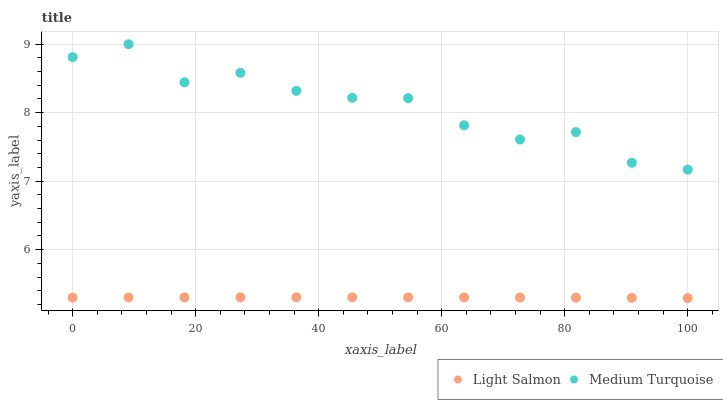Does Light Salmon have the minimum area under the curve?
Answer yes or no. Yes. Does Medium Turquoise have the maximum area under the curve?
Answer yes or no. Yes. Does Medium Turquoise have the minimum area under the curve?
Answer yes or no. No. Is Light Salmon the smoothest?
Answer yes or no. Yes. Is Medium Turquoise the roughest?
Answer yes or no. Yes. Is Medium Turquoise the smoothest?
Answer yes or no. No. Does Light Salmon have the lowest value?
Answer yes or no. Yes. Does Medium Turquoise have the lowest value?
Answer yes or no. No. Does Medium Turquoise have the highest value?
Answer yes or no. Yes. Is Light Salmon less than Medium Turquoise?
Answer yes or no. Yes. Is Medium Turquoise greater than Light Salmon?
Answer yes or no. Yes. Does Light Salmon intersect Medium Turquoise?
Answer yes or no. No. 